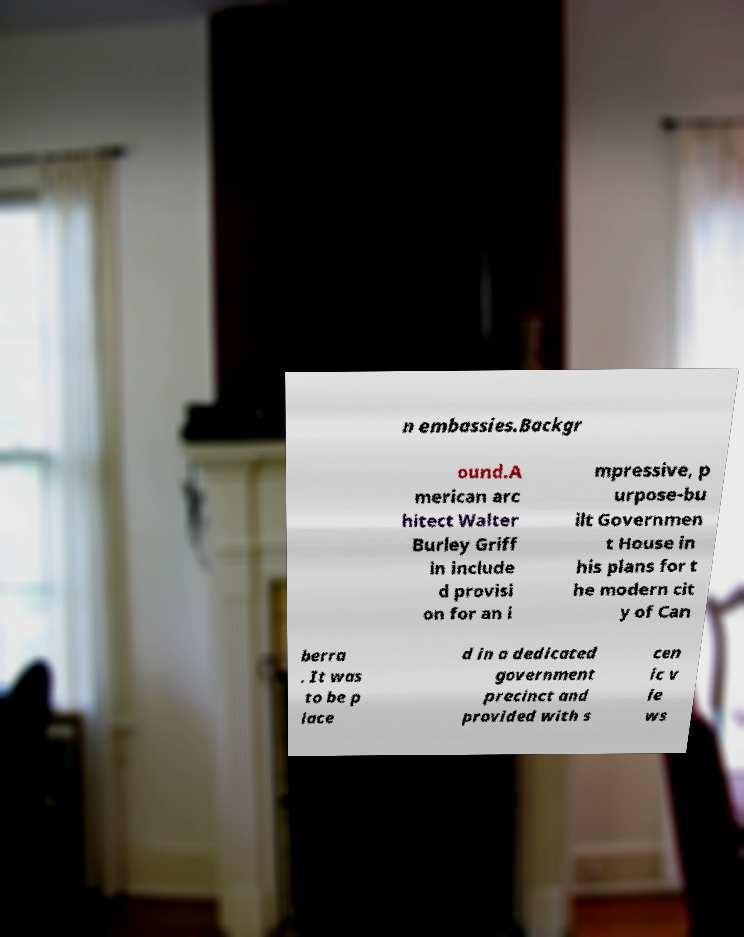Could you extract and type out the text from this image? n embassies.Backgr ound.A merican arc hitect Walter Burley Griff in include d provisi on for an i mpressive, p urpose-bu ilt Governmen t House in his plans for t he modern cit y of Can berra . It was to be p lace d in a dedicated government precinct and provided with s cen ic v ie ws 